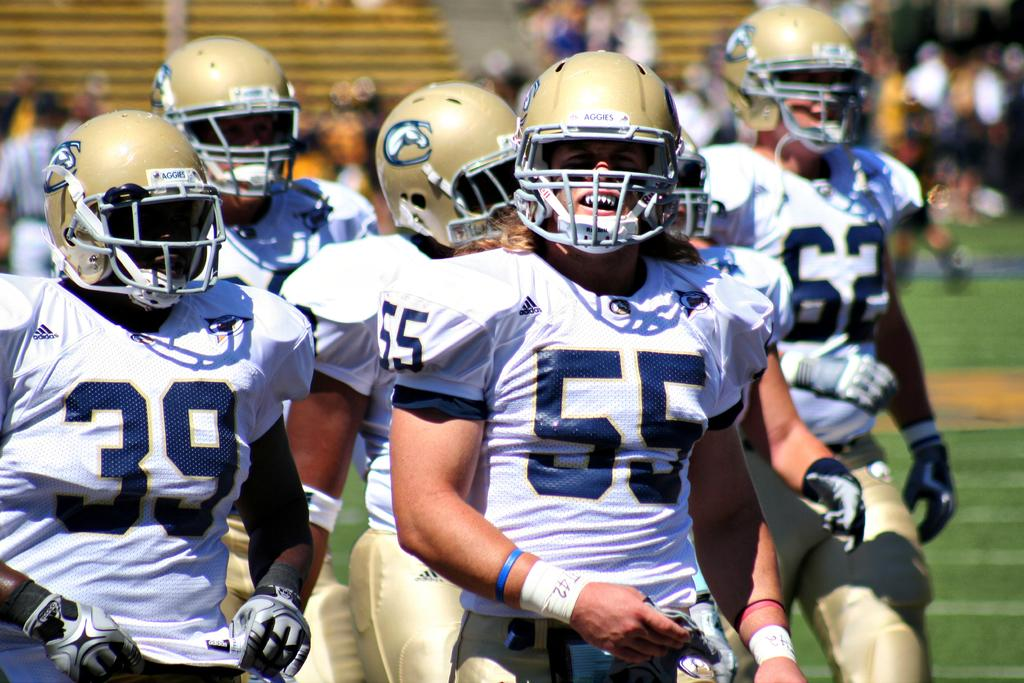What can be seen in the image? There is a group of people in the image. What are the people wearing? The people are wearing the same type of dress and helmets. Are there any distinguishing features on their dresses? Yes, numbers are present on their dresses. Can you see a kite being flown by one of the people in the image? No, there is no kite present in the image. Is there a coil of rope visible near the group of people? No, there is no coil of rope visible in the image. 